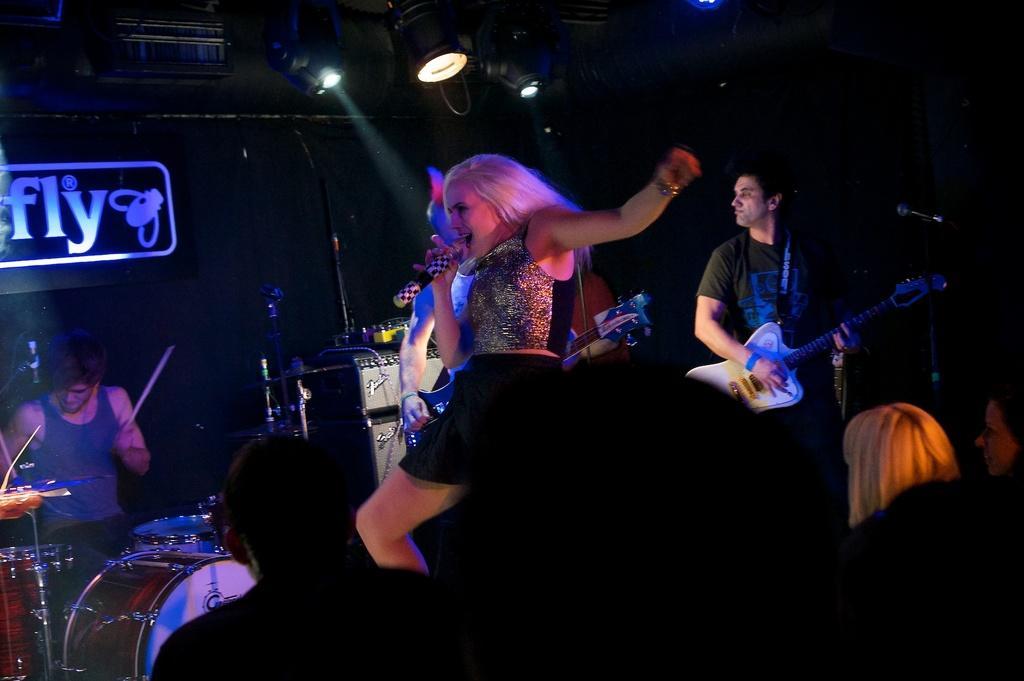Describe this image in one or two sentences. In this image I can see a woman dancing and singing a song using s mike. And these are audience watching the performance. At the left side of the image I can see a man sitting and playing drums. At the right side of the image I can see a man standing and playing guitar. At background I can see a name board with a name fly on it. At top of the image I can see show lights which are used to highlight the show. 